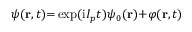Convert formula to latex. <formula><loc_0><loc_0><loc_500><loc_500>\psi ( r , t ) { = } \exp ( i I _ { p } t ) \psi _ { 0 } ( r ) { + } \varphi ( r , t )</formula> 